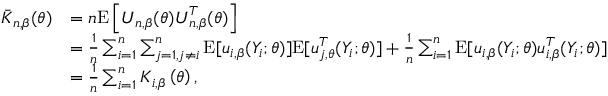<formula> <loc_0><loc_0><loc_500><loc_500>\begin{array} { r l } { \bar { K } _ { n , \beta } ( \theta ) } & { = n E \left [ U _ { n , \beta } ( \theta ) U _ { n , \beta } ^ { T } ( \theta ) \right ] } \\ & { = \frac { 1 } { n } \sum _ { i = 1 } ^ { n } \sum _ { j = 1 , j \neq i } ^ { n } E [ u _ { i , \beta } ( Y _ { i } ; \theta ) ] E [ u _ { j , \theta } ^ { T } ( Y _ { i } ; \theta ) ] + \frac { 1 } { n } \sum _ { i = 1 } ^ { n } E [ u _ { i , \beta } ( Y _ { i } ; \theta ) u _ { i , \beta } ^ { T } ( Y _ { i } ; \theta ) ] } \\ & { = \frac { 1 } { n } \sum _ { i = 1 } ^ { n } K _ { i , \beta } \left ( \theta \right ) , } \end{array}</formula> 